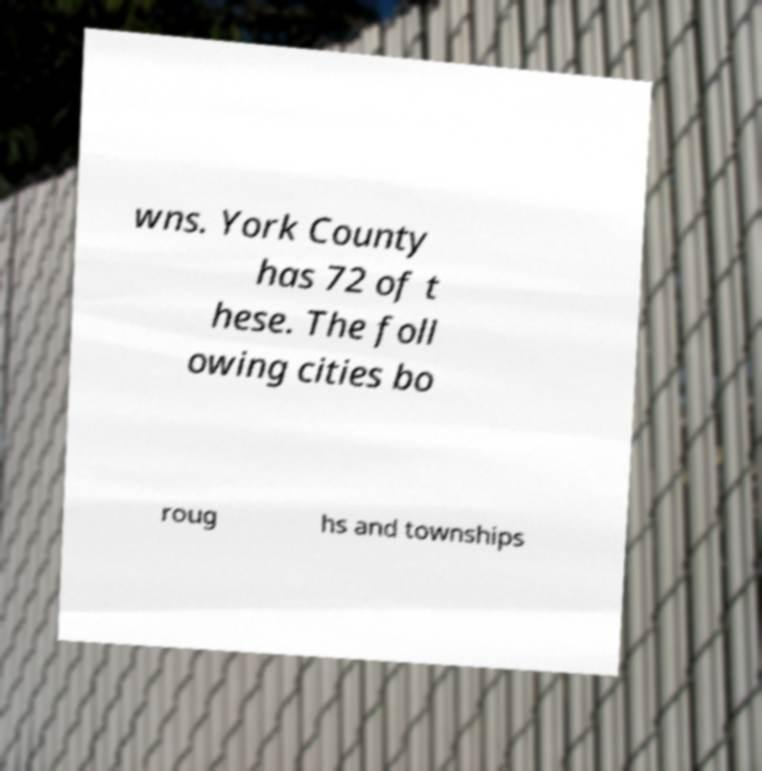What messages or text are displayed in this image? I need them in a readable, typed format. wns. York County has 72 of t hese. The foll owing cities bo roug hs and townships 